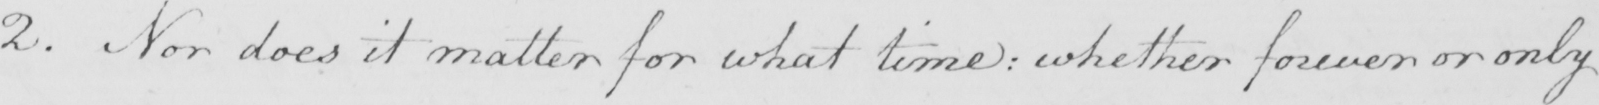Please transcribe the handwritten text in this image. 2 . Nor does it matter for what time :  whether forever or only 